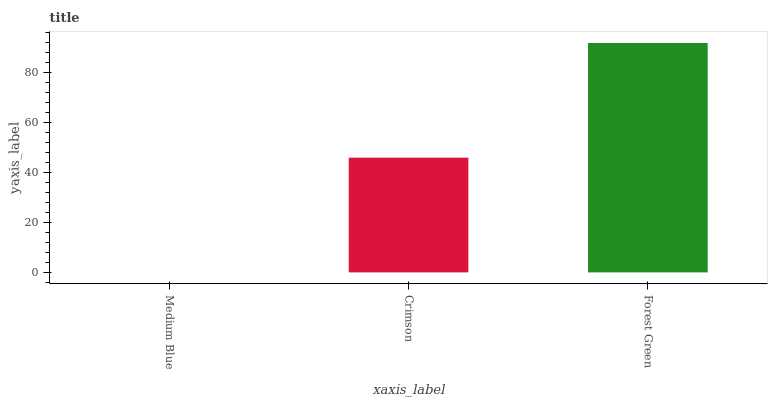Is Medium Blue the minimum?
Answer yes or no. Yes. Is Forest Green the maximum?
Answer yes or no. Yes. Is Crimson the minimum?
Answer yes or no. No. Is Crimson the maximum?
Answer yes or no. No. Is Crimson greater than Medium Blue?
Answer yes or no. Yes. Is Medium Blue less than Crimson?
Answer yes or no. Yes. Is Medium Blue greater than Crimson?
Answer yes or no. No. Is Crimson less than Medium Blue?
Answer yes or no. No. Is Crimson the high median?
Answer yes or no. Yes. Is Crimson the low median?
Answer yes or no. Yes. Is Medium Blue the high median?
Answer yes or no. No. Is Forest Green the low median?
Answer yes or no. No. 